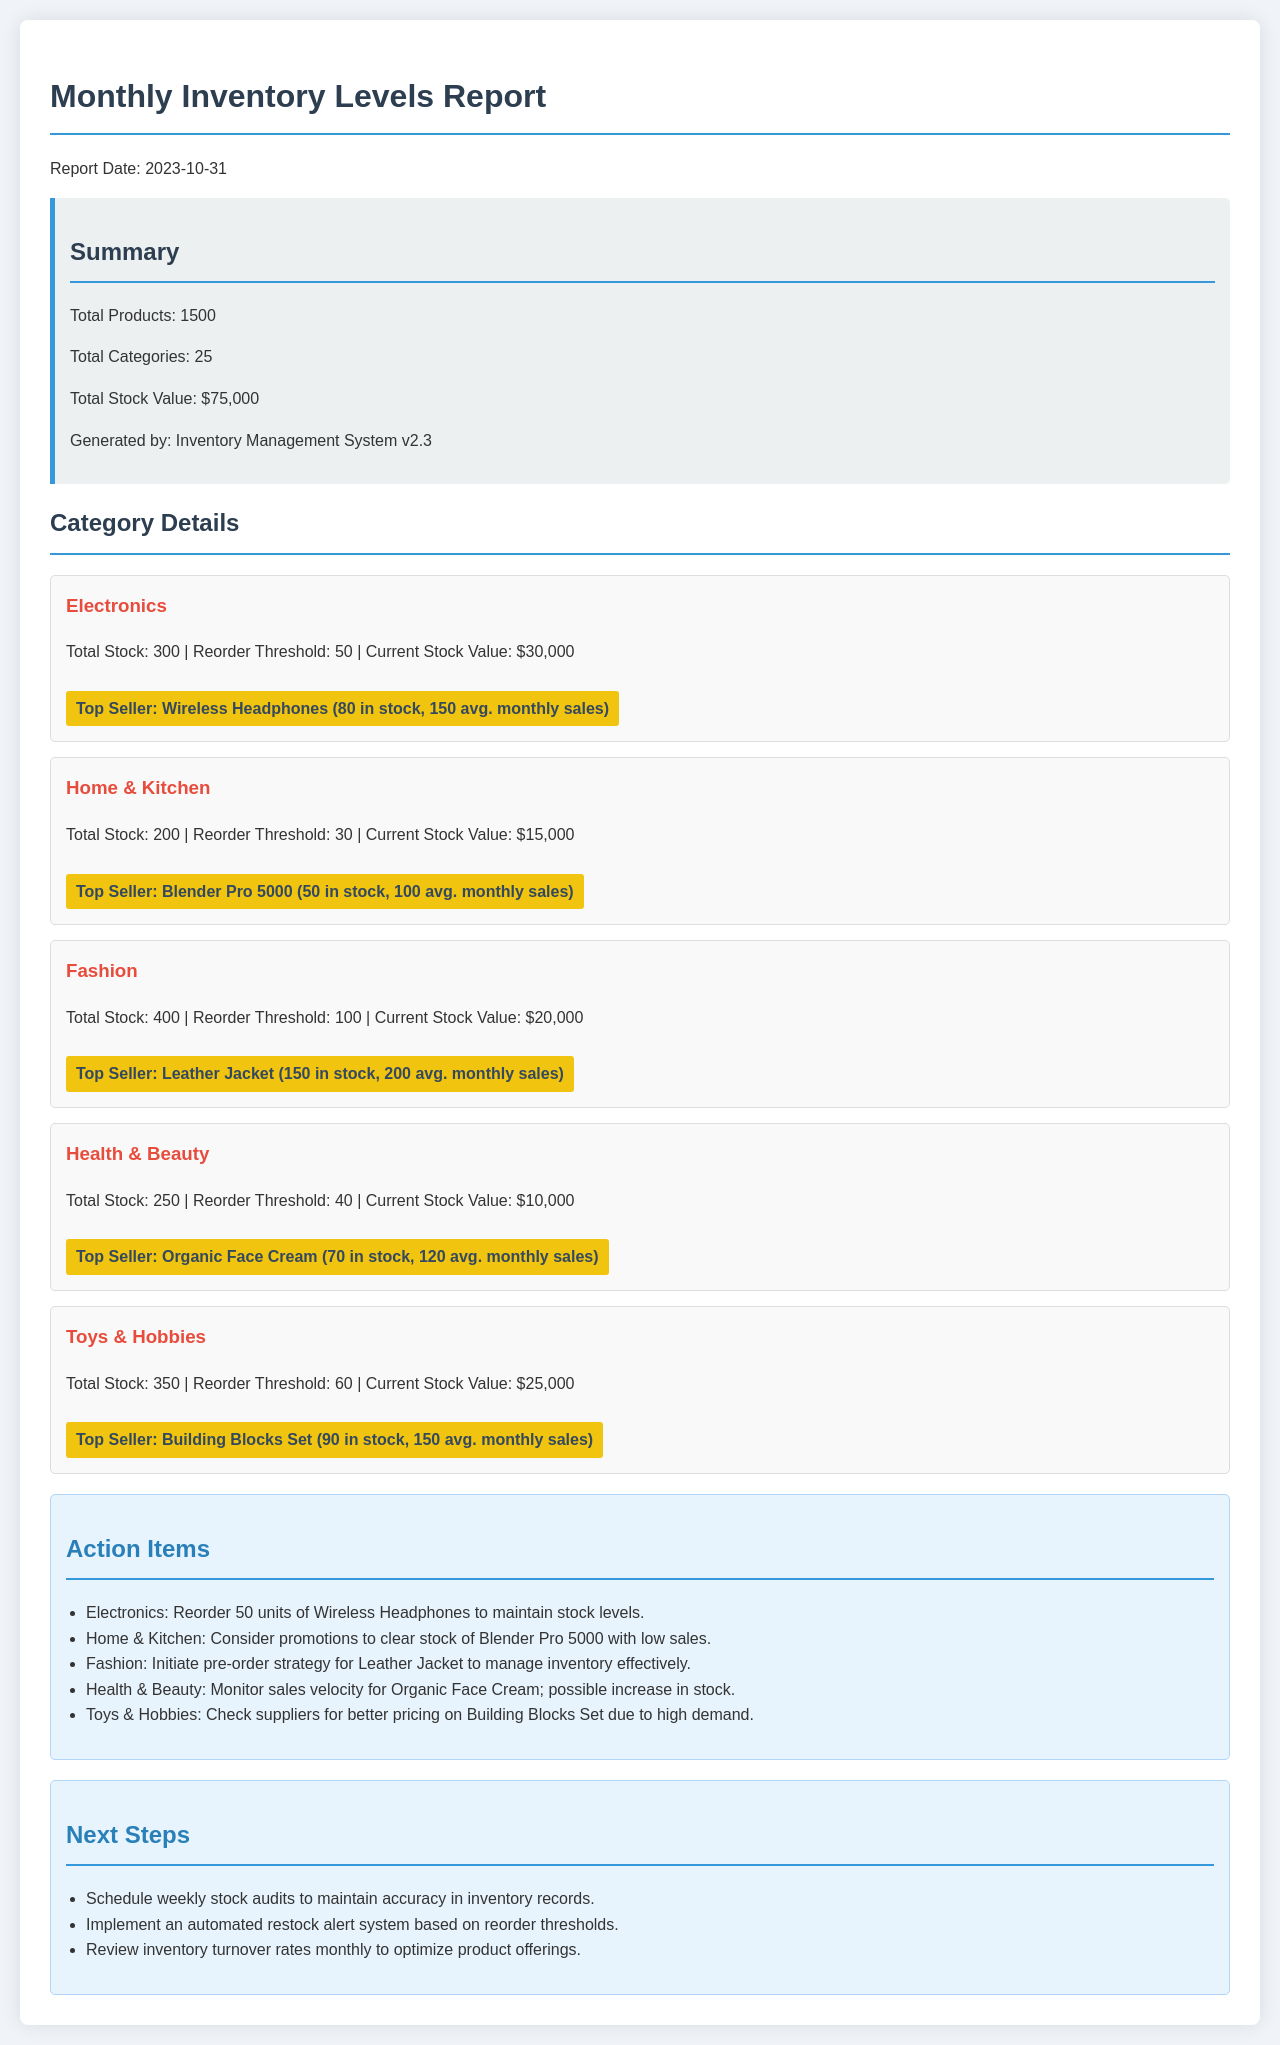what is the report date? The report date is explicitly stated in the document as "2023-10-31."
Answer: 2023-10-31 what is the total number of products? The total number of products is mentioned in the summary section, which states there are 1500 products.
Answer: 1500 what is the total stock value? The total stock value is presented in the summary, totaling $75,000.
Answer: $75,000 which category has the highest stock quantity? In the document, the Fashion category is detailed with a stock of 400 units, which is the highest among other categories.
Answer: Fashion what is the reorder threshold for the Health & Beauty category? The document specifies that the reorder threshold for Health & Beauty is 40 units.
Answer: 40 name the top seller in Electronics The top seller in the Electronics category is explicitly identified as Wireless Headphones.
Answer: Wireless Headphones how many units of the Leather Jacket are currently in stock? The document indicates that 150 units of the Leather Jacket are in stock.
Answer: 150 which action item is suggested for Home & Kitchen? The action item for Home & Kitchen suggests considering promotions to clear stock of the Blender Pro 5000.
Answer: Consider promotions what is one of the next steps mentioned? The document lists the next step of scheduling weekly stock audits to maintain accuracy.
Answer: Schedule weekly stock audits what is the total number of categories? The summary section states that there are 25 categories in total.
Answer: 25 